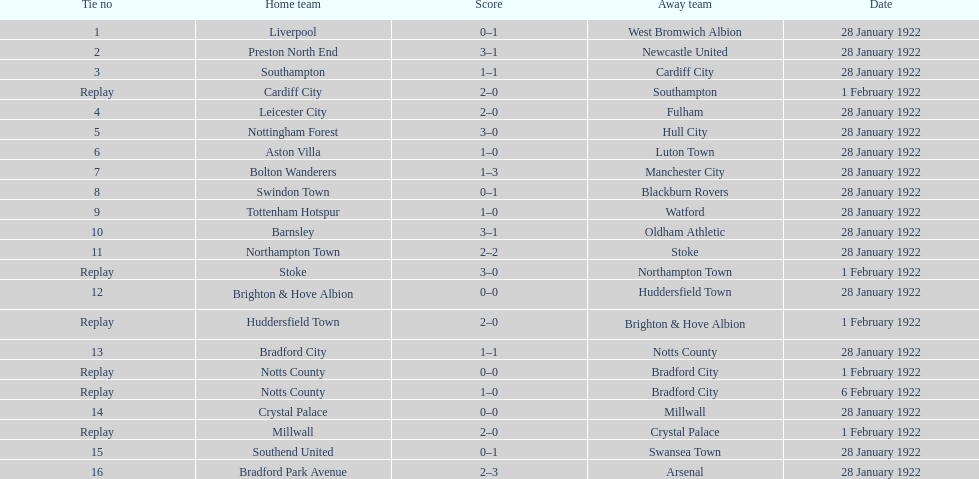What is the number of points scored on 6 february 1922? 1. 